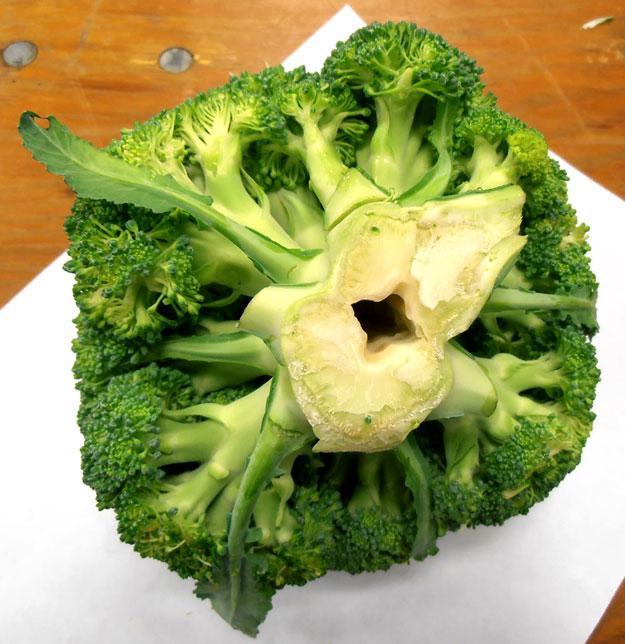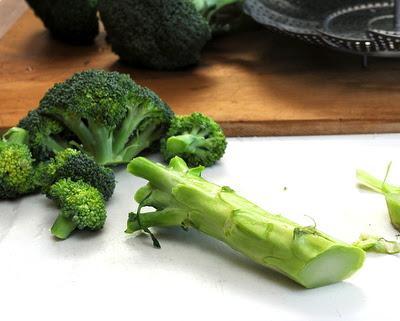The first image is the image on the left, the second image is the image on the right. Evaluate the accuracy of this statement regarding the images: "One image shows broccoli florets in a collander shaped like a dish.". Is it true? Answer yes or no. No. The first image is the image on the left, the second image is the image on the right. Examine the images to the left and right. Is the description "In 1 of the images, there is broccoli on a plate." accurate? Answer yes or no. No. 